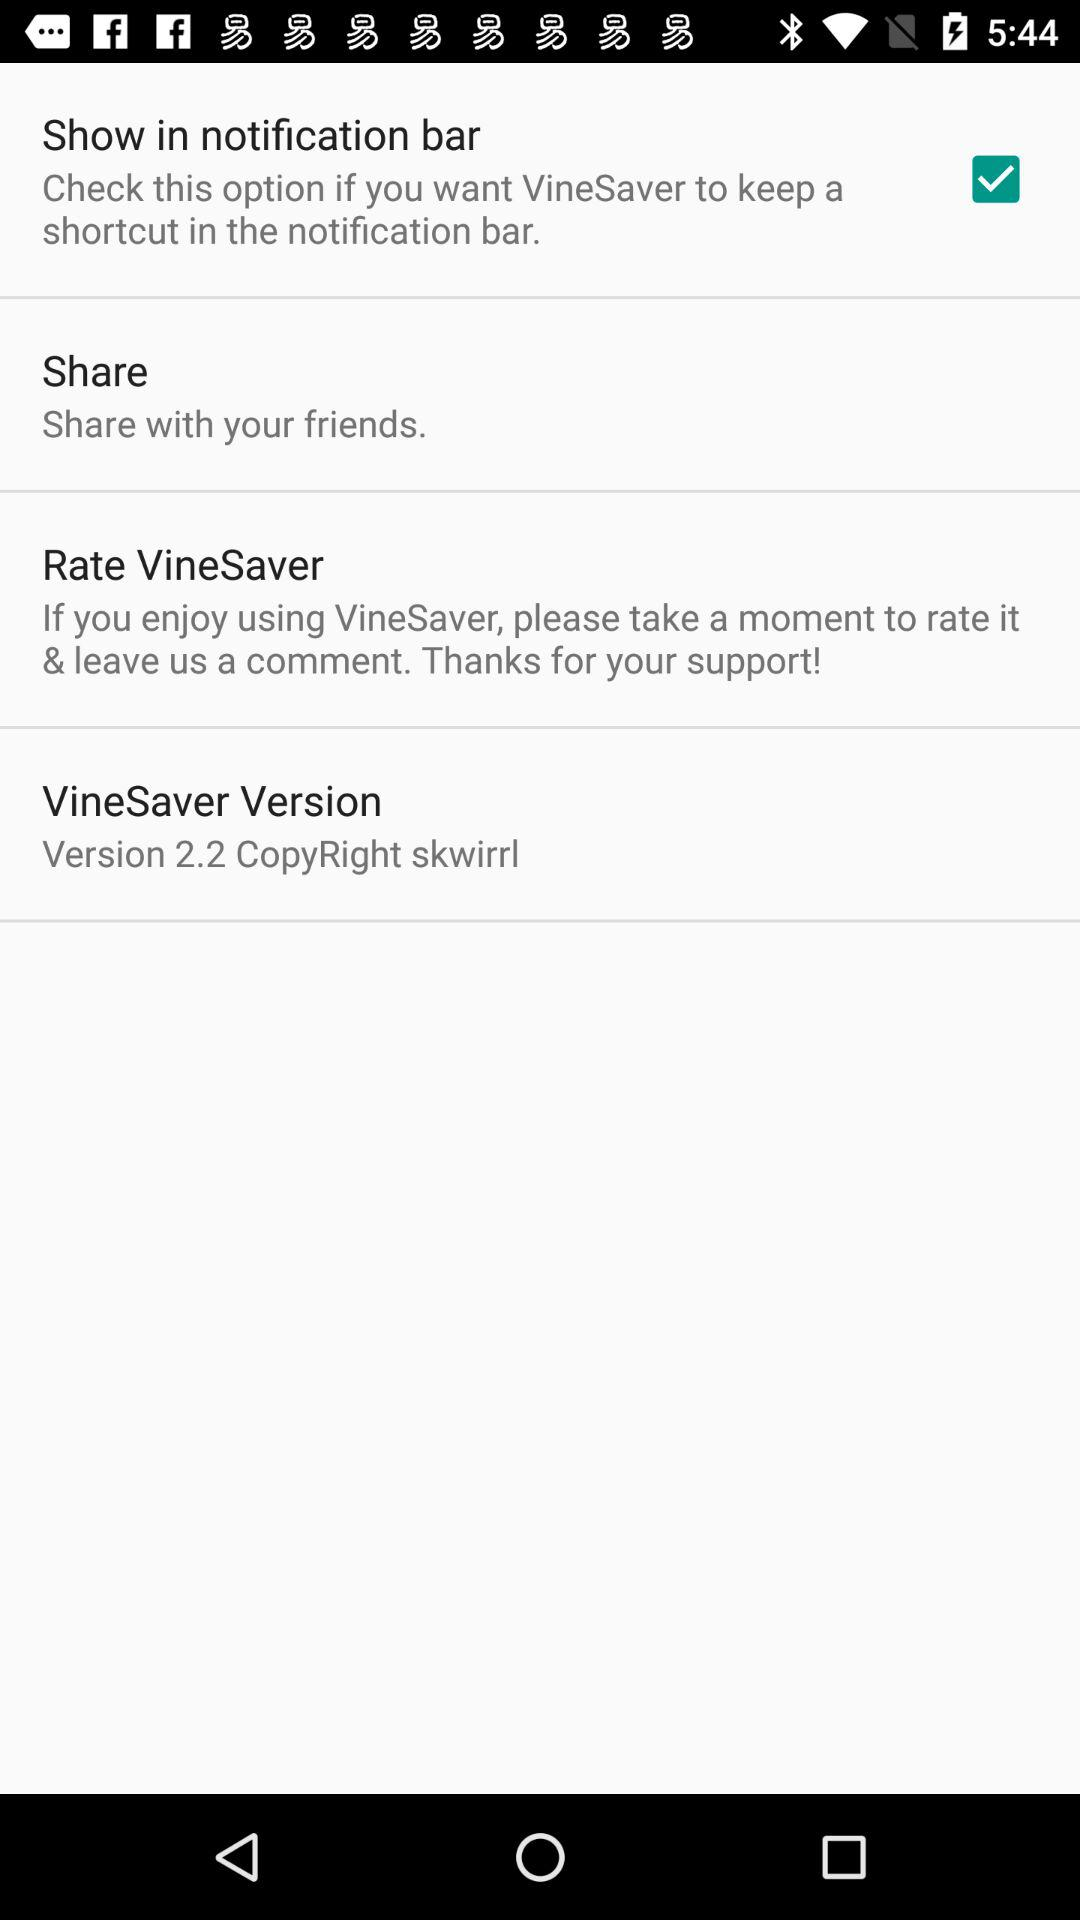What is the name of the application? The name of the application is "VineSaver". 